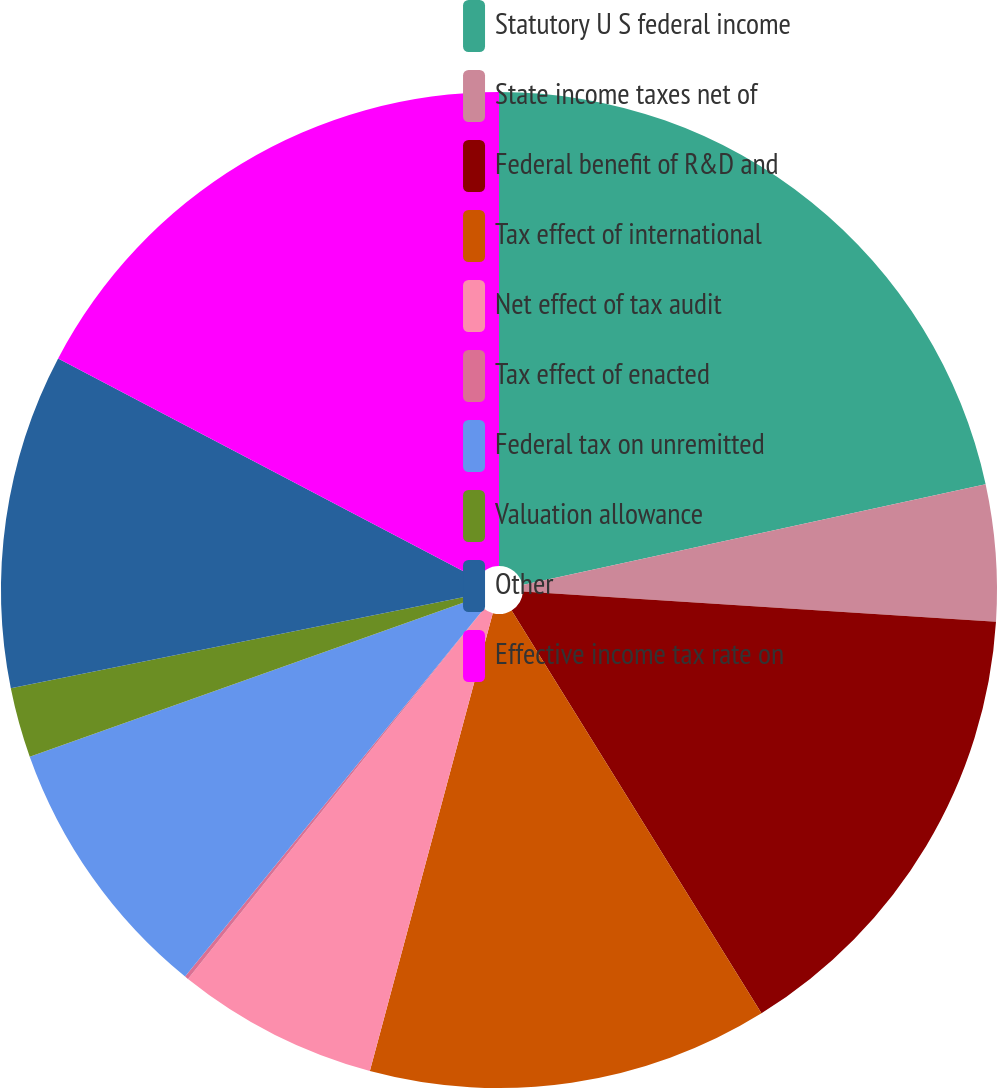Convert chart to OTSL. <chart><loc_0><loc_0><loc_500><loc_500><pie_chart><fcel>Statutory U S federal income<fcel>State income taxes net of<fcel>Federal benefit of R&D and<fcel>Tax effect of international<fcel>Net effect of tax audit<fcel>Tax effect of enacted<fcel>Federal tax on unremitted<fcel>Valuation allowance<fcel>Other<fcel>Effective income tax rate on<nl><fcel>21.59%<fcel>4.42%<fcel>15.15%<fcel>13.01%<fcel>6.56%<fcel>0.12%<fcel>8.71%<fcel>2.27%<fcel>10.86%<fcel>17.3%<nl></chart> 